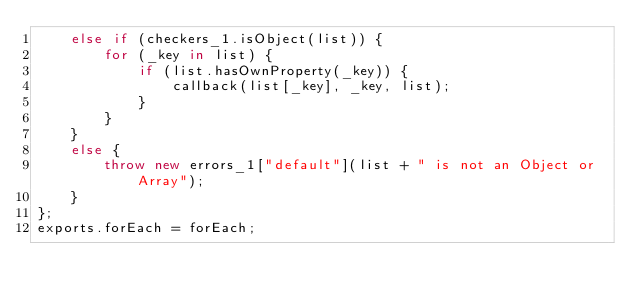Convert code to text. <code><loc_0><loc_0><loc_500><loc_500><_JavaScript_>    else if (checkers_1.isObject(list)) {
        for (_key in list) {
            if (list.hasOwnProperty(_key)) {
                callback(list[_key], _key, list);
            }
        }
    }
    else {
        throw new errors_1["default"](list + " is not an Object or Array");
    }
};
exports.forEach = forEach;
</code> 